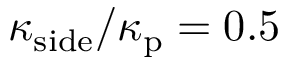Convert formula to latex. <formula><loc_0><loc_0><loc_500><loc_500>\kappa _ { s i d e } / \kappa _ { p } = 0 . 5</formula> 